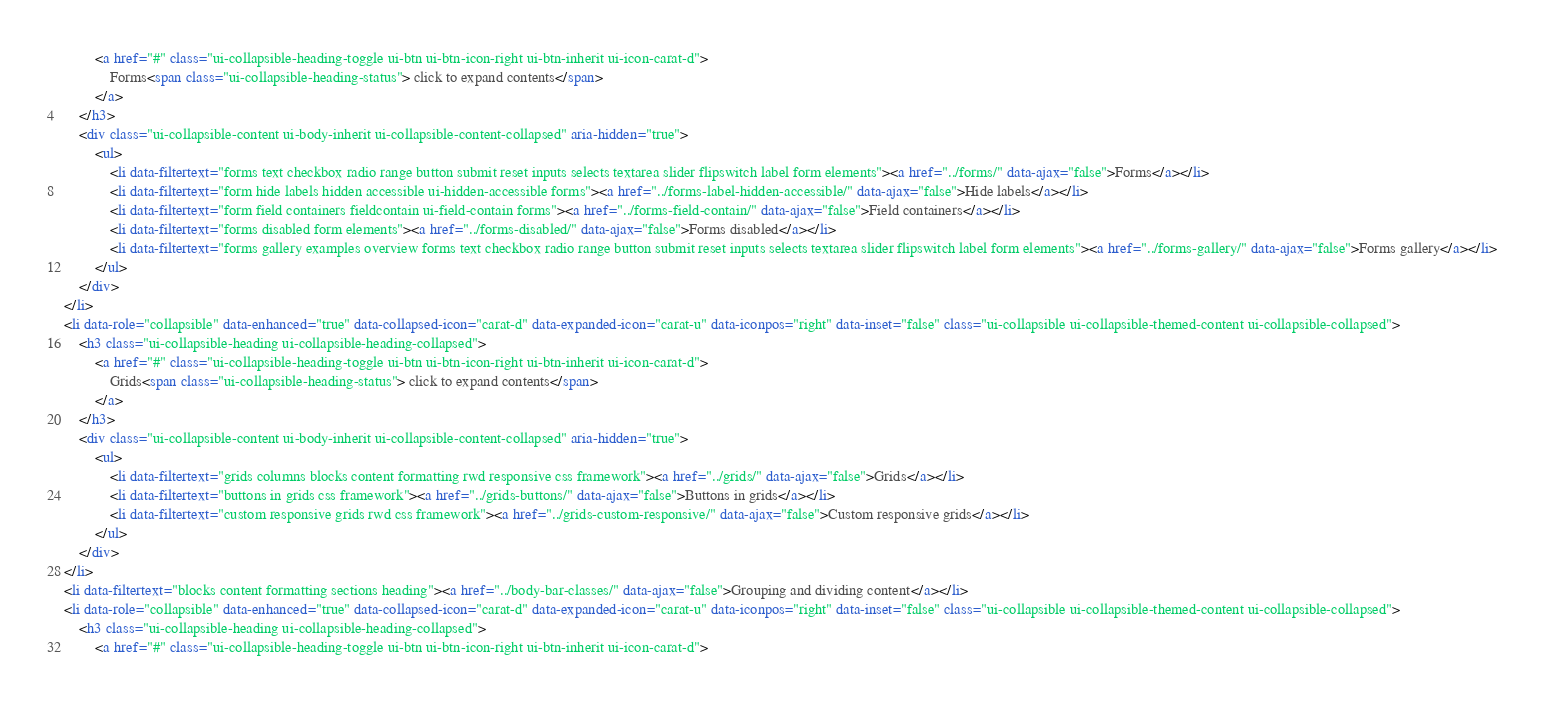<code> <loc_0><loc_0><loc_500><loc_500><_HTML_>		<a href="#" class="ui-collapsible-heading-toggle ui-btn ui-btn-icon-right ui-btn-inherit ui-icon-carat-d">
			Forms<span class="ui-collapsible-heading-status"> click to expand contents</span>
		</a>
	</h3>
	<div class="ui-collapsible-content ui-body-inherit ui-collapsible-content-collapsed" aria-hidden="true">
		<ul>
			<li data-filtertext="forms text checkbox radio range button submit reset inputs selects textarea slider flipswitch label form elements"><a href="../forms/" data-ajax="false">Forms</a></li>
			<li data-filtertext="form hide labels hidden accessible ui-hidden-accessible forms"><a href="../forms-label-hidden-accessible/" data-ajax="false">Hide labels</a></li>
			<li data-filtertext="form field containers fieldcontain ui-field-contain forms"><a href="../forms-field-contain/" data-ajax="false">Field containers</a></li>
			<li data-filtertext="forms disabled form elements"><a href="../forms-disabled/" data-ajax="false">Forms disabled</a></li>
			<li data-filtertext="forms gallery examples overview forms text checkbox radio range button submit reset inputs selects textarea slider flipswitch label form elements"><a href="../forms-gallery/" data-ajax="false">Forms gallery</a></li>
		</ul>
	</div>
</li>
<li data-role="collapsible" data-enhanced="true" data-collapsed-icon="carat-d" data-expanded-icon="carat-u" data-iconpos="right" data-inset="false" class="ui-collapsible ui-collapsible-themed-content ui-collapsible-collapsed">
	<h3 class="ui-collapsible-heading ui-collapsible-heading-collapsed">
		<a href="#" class="ui-collapsible-heading-toggle ui-btn ui-btn-icon-right ui-btn-inherit ui-icon-carat-d">
			Grids<span class="ui-collapsible-heading-status"> click to expand contents</span>
		</a>
	</h3>
	<div class="ui-collapsible-content ui-body-inherit ui-collapsible-content-collapsed" aria-hidden="true">
		<ul>
			<li data-filtertext="grids columns blocks content formatting rwd responsive css framework"><a href="../grids/" data-ajax="false">Grids</a></li>
			<li data-filtertext="buttons in grids css framework"><a href="../grids-buttons/" data-ajax="false">Buttons in grids</a></li>
			<li data-filtertext="custom responsive grids rwd css framework"><a href="../grids-custom-responsive/" data-ajax="false">Custom responsive grids</a></li>
		</ul>
	</div>
</li>
<li data-filtertext="blocks content formatting sections heading"><a href="../body-bar-classes/" data-ajax="false">Grouping and dividing content</a></li>
<li data-role="collapsible" data-enhanced="true" data-collapsed-icon="carat-d" data-expanded-icon="carat-u" data-iconpos="right" data-inset="false" class="ui-collapsible ui-collapsible-themed-content ui-collapsible-collapsed">
	<h3 class="ui-collapsible-heading ui-collapsible-heading-collapsed">
		<a href="#" class="ui-collapsible-heading-toggle ui-btn ui-btn-icon-right ui-btn-inherit ui-icon-carat-d"></code> 